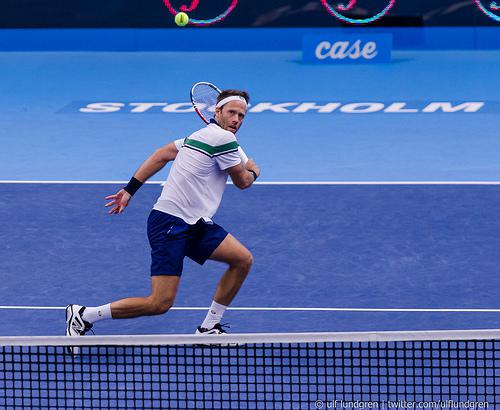Question: what sport is being played?
Choices:
A. Softball.
B. Cricket.
C. Tennis.
D. Football.
Answer with the letter. Answer: C Question: where is the head band?
Choices:
A. Around the man's head.
B. Around his arm.
C. On the table.
D. On the dog.
Answer with the letter. Answer: A Question: what color is the ground?
Choices:
A. Brown.
B. Black.
C. Blue.
D. Grey.
Answer with the letter. Answer: C 